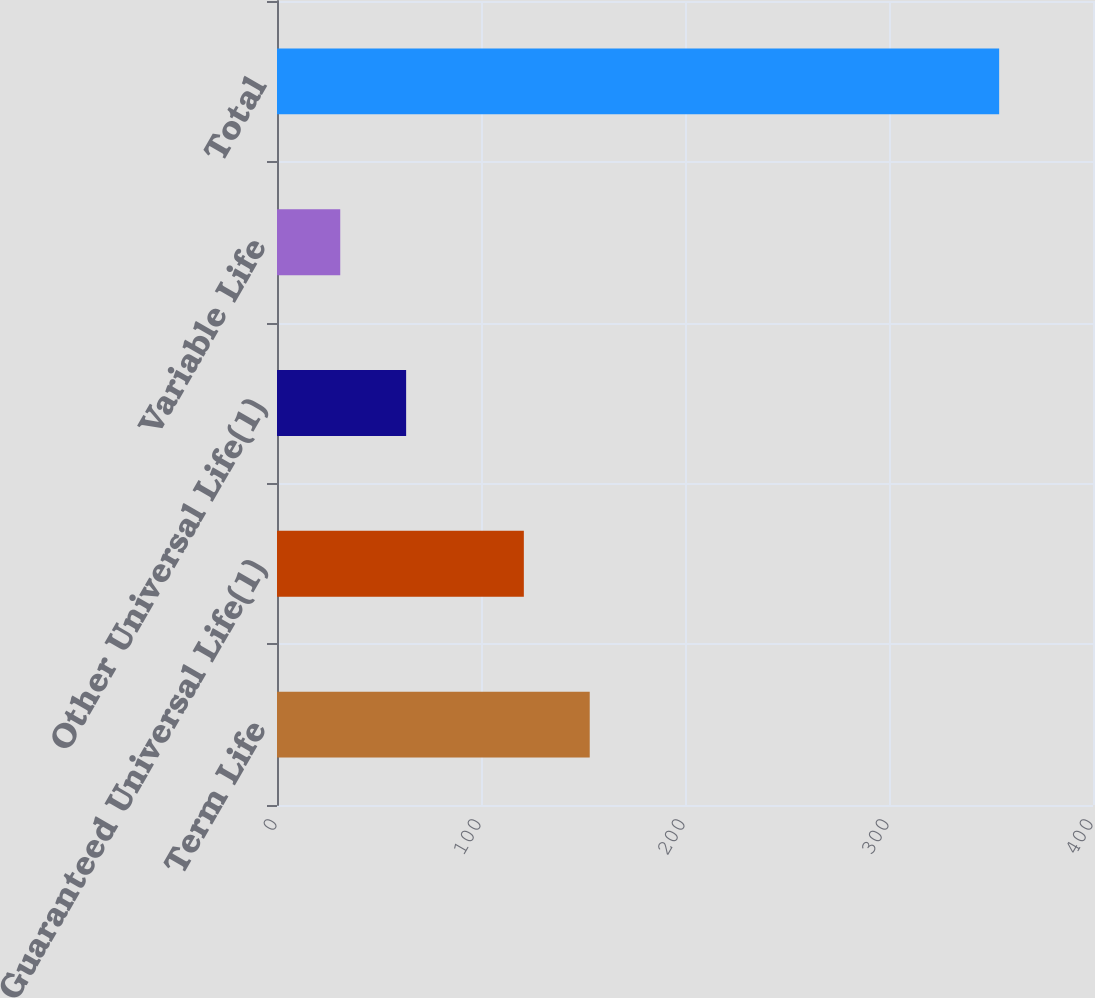<chart> <loc_0><loc_0><loc_500><loc_500><bar_chart><fcel>Term Life<fcel>Guaranteed Universal Life(1)<fcel>Other Universal Life(1)<fcel>Variable Life<fcel>Total<nl><fcel>153.3<fcel>121<fcel>63.3<fcel>31<fcel>354<nl></chart> 